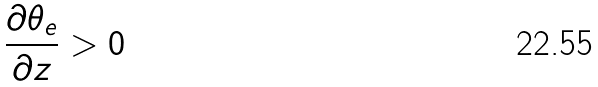Convert formula to latex. <formula><loc_0><loc_0><loc_500><loc_500>\frac { \partial \theta _ { e } } { \partial z } > 0</formula> 